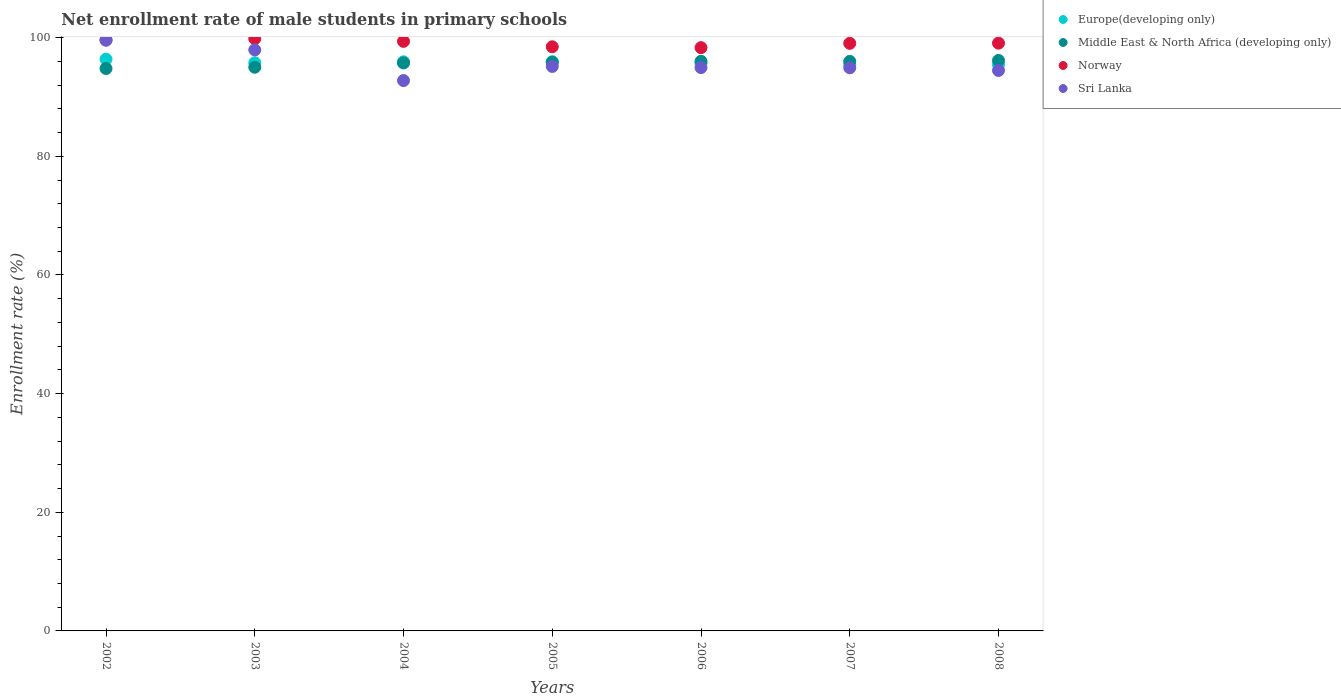Is the number of dotlines equal to the number of legend labels?
Provide a succinct answer. Yes. What is the net enrollment rate of male students in primary schools in Middle East & North Africa (developing only) in 2008?
Your answer should be very brief. 96.17. Across all years, what is the maximum net enrollment rate of male students in primary schools in Middle East & North Africa (developing only)?
Keep it short and to the point. 96.17. Across all years, what is the minimum net enrollment rate of male students in primary schools in Norway?
Your answer should be very brief. 98.32. In which year was the net enrollment rate of male students in primary schools in Europe(developing only) maximum?
Give a very brief answer. 2002. What is the total net enrollment rate of male students in primary schools in Europe(developing only) in the graph?
Ensure brevity in your answer.  670.72. What is the difference between the net enrollment rate of male students in primary schools in Norway in 2002 and that in 2008?
Your response must be concise. 0.55. What is the difference between the net enrollment rate of male students in primary schools in Europe(developing only) in 2003 and the net enrollment rate of male students in primary schools in Norway in 2008?
Keep it short and to the point. -3.31. What is the average net enrollment rate of male students in primary schools in Europe(developing only) per year?
Offer a very short reply. 95.82. In the year 2006, what is the difference between the net enrollment rate of male students in primary schools in Middle East & North Africa (developing only) and net enrollment rate of male students in primary schools in Norway?
Ensure brevity in your answer.  -2.3. What is the ratio of the net enrollment rate of male students in primary schools in Europe(developing only) in 2002 to that in 2007?
Your response must be concise. 1.01. What is the difference between the highest and the second highest net enrollment rate of male students in primary schools in Europe(developing only)?
Ensure brevity in your answer.  0.42. What is the difference between the highest and the lowest net enrollment rate of male students in primary schools in Sri Lanka?
Provide a succinct answer. 6.81. Is the sum of the net enrollment rate of male students in primary schools in Middle East & North Africa (developing only) in 2004 and 2007 greater than the maximum net enrollment rate of male students in primary schools in Europe(developing only) across all years?
Ensure brevity in your answer.  Yes. Does the net enrollment rate of male students in primary schools in Europe(developing only) monotonically increase over the years?
Make the answer very short. No. Is the net enrollment rate of male students in primary schools in Middle East & North Africa (developing only) strictly greater than the net enrollment rate of male students in primary schools in Europe(developing only) over the years?
Offer a terse response. No. Is the net enrollment rate of male students in primary schools in Sri Lanka strictly less than the net enrollment rate of male students in primary schools in Norway over the years?
Give a very brief answer. Yes. What is the difference between two consecutive major ticks on the Y-axis?
Make the answer very short. 20. Does the graph contain any zero values?
Provide a succinct answer. No. Does the graph contain grids?
Provide a succinct answer. No. How many legend labels are there?
Make the answer very short. 4. What is the title of the graph?
Ensure brevity in your answer.  Net enrollment rate of male students in primary schools. What is the label or title of the Y-axis?
Keep it short and to the point. Enrollment rate (%). What is the Enrollment rate (%) of Europe(developing only) in 2002?
Provide a short and direct response. 96.38. What is the Enrollment rate (%) of Middle East & North Africa (developing only) in 2002?
Provide a short and direct response. 94.81. What is the Enrollment rate (%) in Norway in 2002?
Keep it short and to the point. 99.63. What is the Enrollment rate (%) of Sri Lanka in 2002?
Offer a very short reply. 99.58. What is the Enrollment rate (%) in Europe(developing only) in 2003?
Make the answer very short. 95.78. What is the Enrollment rate (%) of Middle East & North Africa (developing only) in 2003?
Offer a very short reply. 95.02. What is the Enrollment rate (%) in Norway in 2003?
Keep it short and to the point. 99.84. What is the Enrollment rate (%) of Sri Lanka in 2003?
Your answer should be very brief. 97.95. What is the Enrollment rate (%) of Europe(developing only) in 2004?
Your response must be concise. 95.94. What is the Enrollment rate (%) in Middle East & North Africa (developing only) in 2004?
Offer a terse response. 95.75. What is the Enrollment rate (%) in Norway in 2004?
Your answer should be compact. 99.39. What is the Enrollment rate (%) of Sri Lanka in 2004?
Give a very brief answer. 92.78. What is the Enrollment rate (%) in Europe(developing only) in 2005?
Your answer should be very brief. 95.96. What is the Enrollment rate (%) of Middle East & North Africa (developing only) in 2005?
Offer a very short reply. 95.85. What is the Enrollment rate (%) of Norway in 2005?
Ensure brevity in your answer.  98.47. What is the Enrollment rate (%) in Sri Lanka in 2005?
Your answer should be compact. 95.16. What is the Enrollment rate (%) in Europe(developing only) in 2006?
Give a very brief answer. 95.71. What is the Enrollment rate (%) of Middle East & North Africa (developing only) in 2006?
Your answer should be compact. 96.03. What is the Enrollment rate (%) in Norway in 2006?
Give a very brief answer. 98.32. What is the Enrollment rate (%) in Sri Lanka in 2006?
Your response must be concise. 94.97. What is the Enrollment rate (%) in Europe(developing only) in 2007?
Offer a terse response. 95.49. What is the Enrollment rate (%) of Middle East & North Africa (developing only) in 2007?
Give a very brief answer. 96. What is the Enrollment rate (%) of Norway in 2007?
Give a very brief answer. 99.05. What is the Enrollment rate (%) in Sri Lanka in 2007?
Offer a terse response. 94.93. What is the Enrollment rate (%) of Europe(developing only) in 2008?
Offer a very short reply. 95.46. What is the Enrollment rate (%) in Middle East & North Africa (developing only) in 2008?
Offer a terse response. 96.17. What is the Enrollment rate (%) of Norway in 2008?
Your answer should be compact. 99.09. What is the Enrollment rate (%) in Sri Lanka in 2008?
Your answer should be very brief. 94.48. Across all years, what is the maximum Enrollment rate (%) of Europe(developing only)?
Make the answer very short. 96.38. Across all years, what is the maximum Enrollment rate (%) in Middle East & North Africa (developing only)?
Your answer should be compact. 96.17. Across all years, what is the maximum Enrollment rate (%) in Norway?
Give a very brief answer. 99.84. Across all years, what is the maximum Enrollment rate (%) in Sri Lanka?
Your answer should be compact. 99.58. Across all years, what is the minimum Enrollment rate (%) of Europe(developing only)?
Provide a short and direct response. 95.46. Across all years, what is the minimum Enrollment rate (%) of Middle East & North Africa (developing only)?
Keep it short and to the point. 94.81. Across all years, what is the minimum Enrollment rate (%) in Norway?
Provide a short and direct response. 98.32. Across all years, what is the minimum Enrollment rate (%) in Sri Lanka?
Give a very brief answer. 92.78. What is the total Enrollment rate (%) in Europe(developing only) in the graph?
Offer a terse response. 670.72. What is the total Enrollment rate (%) of Middle East & North Africa (developing only) in the graph?
Ensure brevity in your answer.  669.63. What is the total Enrollment rate (%) of Norway in the graph?
Your answer should be compact. 693.79. What is the total Enrollment rate (%) in Sri Lanka in the graph?
Provide a short and direct response. 669.84. What is the difference between the Enrollment rate (%) in Europe(developing only) in 2002 and that in 2003?
Provide a succinct answer. 0.6. What is the difference between the Enrollment rate (%) of Middle East & North Africa (developing only) in 2002 and that in 2003?
Ensure brevity in your answer.  -0.21. What is the difference between the Enrollment rate (%) in Norway in 2002 and that in 2003?
Provide a short and direct response. -0.21. What is the difference between the Enrollment rate (%) of Sri Lanka in 2002 and that in 2003?
Offer a terse response. 1.63. What is the difference between the Enrollment rate (%) in Europe(developing only) in 2002 and that in 2004?
Your answer should be compact. 0.44. What is the difference between the Enrollment rate (%) in Middle East & North Africa (developing only) in 2002 and that in 2004?
Keep it short and to the point. -0.94. What is the difference between the Enrollment rate (%) of Norway in 2002 and that in 2004?
Your answer should be very brief. 0.24. What is the difference between the Enrollment rate (%) of Sri Lanka in 2002 and that in 2004?
Provide a short and direct response. 6.81. What is the difference between the Enrollment rate (%) of Europe(developing only) in 2002 and that in 2005?
Your answer should be very brief. 0.42. What is the difference between the Enrollment rate (%) of Middle East & North Africa (developing only) in 2002 and that in 2005?
Offer a very short reply. -1.05. What is the difference between the Enrollment rate (%) of Norway in 2002 and that in 2005?
Your response must be concise. 1.16. What is the difference between the Enrollment rate (%) of Sri Lanka in 2002 and that in 2005?
Make the answer very short. 4.43. What is the difference between the Enrollment rate (%) in Europe(developing only) in 2002 and that in 2006?
Your answer should be compact. 0.67. What is the difference between the Enrollment rate (%) in Middle East & North Africa (developing only) in 2002 and that in 2006?
Provide a short and direct response. -1.22. What is the difference between the Enrollment rate (%) in Norway in 2002 and that in 2006?
Your answer should be compact. 1.31. What is the difference between the Enrollment rate (%) in Sri Lanka in 2002 and that in 2006?
Provide a short and direct response. 4.62. What is the difference between the Enrollment rate (%) in Europe(developing only) in 2002 and that in 2007?
Ensure brevity in your answer.  0.89. What is the difference between the Enrollment rate (%) of Middle East & North Africa (developing only) in 2002 and that in 2007?
Your response must be concise. -1.19. What is the difference between the Enrollment rate (%) in Norway in 2002 and that in 2007?
Give a very brief answer. 0.58. What is the difference between the Enrollment rate (%) of Sri Lanka in 2002 and that in 2007?
Provide a succinct answer. 4.65. What is the difference between the Enrollment rate (%) in Europe(developing only) in 2002 and that in 2008?
Your answer should be very brief. 0.92. What is the difference between the Enrollment rate (%) of Middle East & North Africa (developing only) in 2002 and that in 2008?
Provide a short and direct response. -1.36. What is the difference between the Enrollment rate (%) of Norway in 2002 and that in 2008?
Offer a very short reply. 0.55. What is the difference between the Enrollment rate (%) of Sri Lanka in 2002 and that in 2008?
Provide a short and direct response. 5.11. What is the difference between the Enrollment rate (%) in Europe(developing only) in 2003 and that in 2004?
Give a very brief answer. -0.16. What is the difference between the Enrollment rate (%) of Middle East & North Africa (developing only) in 2003 and that in 2004?
Your answer should be very brief. -0.72. What is the difference between the Enrollment rate (%) in Norway in 2003 and that in 2004?
Ensure brevity in your answer.  0.45. What is the difference between the Enrollment rate (%) in Sri Lanka in 2003 and that in 2004?
Your answer should be very brief. 5.17. What is the difference between the Enrollment rate (%) of Europe(developing only) in 2003 and that in 2005?
Your response must be concise. -0.18. What is the difference between the Enrollment rate (%) of Middle East & North Africa (developing only) in 2003 and that in 2005?
Provide a succinct answer. -0.83. What is the difference between the Enrollment rate (%) in Norway in 2003 and that in 2005?
Offer a very short reply. 1.37. What is the difference between the Enrollment rate (%) of Sri Lanka in 2003 and that in 2005?
Ensure brevity in your answer.  2.79. What is the difference between the Enrollment rate (%) of Europe(developing only) in 2003 and that in 2006?
Give a very brief answer. 0.07. What is the difference between the Enrollment rate (%) of Middle East & North Africa (developing only) in 2003 and that in 2006?
Make the answer very short. -1. What is the difference between the Enrollment rate (%) of Norway in 2003 and that in 2006?
Ensure brevity in your answer.  1.52. What is the difference between the Enrollment rate (%) of Sri Lanka in 2003 and that in 2006?
Offer a terse response. 2.98. What is the difference between the Enrollment rate (%) of Europe(developing only) in 2003 and that in 2007?
Make the answer very short. 0.29. What is the difference between the Enrollment rate (%) of Middle East & North Africa (developing only) in 2003 and that in 2007?
Offer a very short reply. -0.98. What is the difference between the Enrollment rate (%) of Norway in 2003 and that in 2007?
Make the answer very short. 0.79. What is the difference between the Enrollment rate (%) in Sri Lanka in 2003 and that in 2007?
Your answer should be compact. 3.02. What is the difference between the Enrollment rate (%) of Europe(developing only) in 2003 and that in 2008?
Your answer should be compact. 0.31. What is the difference between the Enrollment rate (%) in Middle East & North Africa (developing only) in 2003 and that in 2008?
Keep it short and to the point. -1.14. What is the difference between the Enrollment rate (%) in Norway in 2003 and that in 2008?
Make the answer very short. 0.75. What is the difference between the Enrollment rate (%) of Sri Lanka in 2003 and that in 2008?
Ensure brevity in your answer.  3.47. What is the difference between the Enrollment rate (%) of Europe(developing only) in 2004 and that in 2005?
Make the answer very short. -0.02. What is the difference between the Enrollment rate (%) of Middle East & North Africa (developing only) in 2004 and that in 2005?
Keep it short and to the point. -0.11. What is the difference between the Enrollment rate (%) in Norway in 2004 and that in 2005?
Provide a succinct answer. 0.92. What is the difference between the Enrollment rate (%) of Sri Lanka in 2004 and that in 2005?
Give a very brief answer. -2.38. What is the difference between the Enrollment rate (%) of Europe(developing only) in 2004 and that in 2006?
Your answer should be very brief. 0.23. What is the difference between the Enrollment rate (%) in Middle East & North Africa (developing only) in 2004 and that in 2006?
Your response must be concise. -0.28. What is the difference between the Enrollment rate (%) in Norway in 2004 and that in 2006?
Provide a succinct answer. 1.06. What is the difference between the Enrollment rate (%) in Sri Lanka in 2004 and that in 2006?
Your answer should be very brief. -2.19. What is the difference between the Enrollment rate (%) of Europe(developing only) in 2004 and that in 2007?
Your response must be concise. 0.45. What is the difference between the Enrollment rate (%) in Middle East & North Africa (developing only) in 2004 and that in 2007?
Keep it short and to the point. -0.26. What is the difference between the Enrollment rate (%) in Norway in 2004 and that in 2007?
Provide a succinct answer. 0.34. What is the difference between the Enrollment rate (%) in Sri Lanka in 2004 and that in 2007?
Make the answer very short. -2.15. What is the difference between the Enrollment rate (%) in Europe(developing only) in 2004 and that in 2008?
Provide a short and direct response. 0.48. What is the difference between the Enrollment rate (%) in Middle East & North Africa (developing only) in 2004 and that in 2008?
Provide a short and direct response. -0.42. What is the difference between the Enrollment rate (%) of Norway in 2004 and that in 2008?
Provide a short and direct response. 0.3. What is the difference between the Enrollment rate (%) of Sri Lanka in 2004 and that in 2008?
Keep it short and to the point. -1.7. What is the difference between the Enrollment rate (%) of Europe(developing only) in 2005 and that in 2006?
Offer a terse response. 0.25. What is the difference between the Enrollment rate (%) of Middle East & North Africa (developing only) in 2005 and that in 2006?
Give a very brief answer. -0.17. What is the difference between the Enrollment rate (%) in Norway in 2005 and that in 2006?
Provide a succinct answer. 0.15. What is the difference between the Enrollment rate (%) of Sri Lanka in 2005 and that in 2006?
Provide a succinct answer. 0.19. What is the difference between the Enrollment rate (%) in Europe(developing only) in 2005 and that in 2007?
Offer a terse response. 0.47. What is the difference between the Enrollment rate (%) in Middle East & North Africa (developing only) in 2005 and that in 2007?
Keep it short and to the point. -0.15. What is the difference between the Enrollment rate (%) in Norway in 2005 and that in 2007?
Offer a terse response. -0.58. What is the difference between the Enrollment rate (%) of Sri Lanka in 2005 and that in 2007?
Make the answer very short. 0.23. What is the difference between the Enrollment rate (%) of Europe(developing only) in 2005 and that in 2008?
Make the answer very short. 0.49. What is the difference between the Enrollment rate (%) in Middle East & North Africa (developing only) in 2005 and that in 2008?
Your response must be concise. -0.31. What is the difference between the Enrollment rate (%) of Norway in 2005 and that in 2008?
Offer a terse response. -0.61. What is the difference between the Enrollment rate (%) in Sri Lanka in 2005 and that in 2008?
Provide a short and direct response. 0.68. What is the difference between the Enrollment rate (%) of Europe(developing only) in 2006 and that in 2007?
Provide a succinct answer. 0.22. What is the difference between the Enrollment rate (%) of Middle East & North Africa (developing only) in 2006 and that in 2007?
Your answer should be very brief. 0.02. What is the difference between the Enrollment rate (%) in Norway in 2006 and that in 2007?
Give a very brief answer. -0.73. What is the difference between the Enrollment rate (%) of Sri Lanka in 2006 and that in 2007?
Provide a short and direct response. 0.04. What is the difference between the Enrollment rate (%) in Europe(developing only) in 2006 and that in 2008?
Offer a terse response. 0.25. What is the difference between the Enrollment rate (%) of Middle East & North Africa (developing only) in 2006 and that in 2008?
Offer a terse response. -0.14. What is the difference between the Enrollment rate (%) in Norway in 2006 and that in 2008?
Provide a succinct answer. -0.76. What is the difference between the Enrollment rate (%) of Sri Lanka in 2006 and that in 2008?
Offer a terse response. 0.49. What is the difference between the Enrollment rate (%) of Europe(developing only) in 2007 and that in 2008?
Keep it short and to the point. 0.02. What is the difference between the Enrollment rate (%) of Middle East & North Africa (developing only) in 2007 and that in 2008?
Provide a succinct answer. -0.16. What is the difference between the Enrollment rate (%) of Norway in 2007 and that in 2008?
Your response must be concise. -0.03. What is the difference between the Enrollment rate (%) in Sri Lanka in 2007 and that in 2008?
Your answer should be compact. 0.45. What is the difference between the Enrollment rate (%) of Europe(developing only) in 2002 and the Enrollment rate (%) of Middle East & North Africa (developing only) in 2003?
Provide a succinct answer. 1.36. What is the difference between the Enrollment rate (%) of Europe(developing only) in 2002 and the Enrollment rate (%) of Norway in 2003?
Offer a very short reply. -3.46. What is the difference between the Enrollment rate (%) of Europe(developing only) in 2002 and the Enrollment rate (%) of Sri Lanka in 2003?
Your response must be concise. -1.57. What is the difference between the Enrollment rate (%) of Middle East & North Africa (developing only) in 2002 and the Enrollment rate (%) of Norway in 2003?
Offer a terse response. -5.03. What is the difference between the Enrollment rate (%) of Middle East & North Africa (developing only) in 2002 and the Enrollment rate (%) of Sri Lanka in 2003?
Give a very brief answer. -3.14. What is the difference between the Enrollment rate (%) in Norway in 2002 and the Enrollment rate (%) in Sri Lanka in 2003?
Ensure brevity in your answer.  1.68. What is the difference between the Enrollment rate (%) of Europe(developing only) in 2002 and the Enrollment rate (%) of Middle East & North Africa (developing only) in 2004?
Provide a short and direct response. 0.63. What is the difference between the Enrollment rate (%) in Europe(developing only) in 2002 and the Enrollment rate (%) in Norway in 2004?
Provide a short and direct response. -3.01. What is the difference between the Enrollment rate (%) of Europe(developing only) in 2002 and the Enrollment rate (%) of Sri Lanka in 2004?
Give a very brief answer. 3.61. What is the difference between the Enrollment rate (%) of Middle East & North Africa (developing only) in 2002 and the Enrollment rate (%) of Norway in 2004?
Make the answer very short. -4.58. What is the difference between the Enrollment rate (%) of Middle East & North Africa (developing only) in 2002 and the Enrollment rate (%) of Sri Lanka in 2004?
Provide a short and direct response. 2.03. What is the difference between the Enrollment rate (%) in Norway in 2002 and the Enrollment rate (%) in Sri Lanka in 2004?
Keep it short and to the point. 6.86. What is the difference between the Enrollment rate (%) of Europe(developing only) in 2002 and the Enrollment rate (%) of Middle East & North Africa (developing only) in 2005?
Offer a terse response. 0.53. What is the difference between the Enrollment rate (%) of Europe(developing only) in 2002 and the Enrollment rate (%) of Norway in 2005?
Provide a short and direct response. -2.09. What is the difference between the Enrollment rate (%) of Europe(developing only) in 2002 and the Enrollment rate (%) of Sri Lanka in 2005?
Provide a succinct answer. 1.22. What is the difference between the Enrollment rate (%) in Middle East & North Africa (developing only) in 2002 and the Enrollment rate (%) in Norway in 2005?
Make the answer very short. -3.66. What is the difference between the Enrollment rate (%) of Middle East & North Africa (developing only) in 2002 and the Enrollment rate (%) of Sri Lanka in 2005?
Keep it short and to the point. -0.35. What is the difference between the Enrollment rate (%) in Norway in 2002 and the Enrollment rate (%) in Sri Lanka in 2005?
Your answer should be compact. 4.47. What is the difference between the Enrollment rate (%) in Europe(developing only) in 2002 and the Enrollment rate (%) in Middle East & North Africa (developing only) in 2006?
Your answer should be compact. 0.36. What is the difference between the Enrollment rate (%) in Europe(developing only) in 2002 and the Enrollment rate (%) in Norway in 2006?
Provide a succinct answer. -1.94. What is the difference between the Enrollment rate (%) in Europe(developing only) in 2002 and the Enrollment rate (%) in Sri Lanka in 2006?
Make the answer very short. 1.42. What is the difference between the Enrollment rate (%) of Middle East & North Africa (developing only) in 2002 and the Enrollment rate (%) of Norway in 2006?
Your response must be concise. -3.51. What is the difference between the Enrollment rate (%) in Middle East & North Africa (developing only) in 2002 and the Enrollment rate (%) in Sri Lanka in 2006?
Offer a very short reply. -0.16. What is the difference between the Enrollment rate (%) in Norway in 2002 and the Enrollment rate (%) in Sri Lanka in 2006?
Make the answer very short. 4.67. What is the difference between the Enrollment rate (%) in Europe(developing only) in 2002 and the Enrollment rate (%) in Middle East & North Africa (developing only) in 2007?
Provide a succinct answer. 0.38. What is the difference between the Enrollment rate (%) in Europe(developing only) in 2002 and the Enrollment rate (%) in Norway in 2007?
Your answer should be very brief. -2.67. What is the difference between the Enrollment rate (%) in Europe(developing only) in 2002 and the Enrollment rate (%) in Sri Lanka in 2007?
Your answer should be compact. 1.45. What is the difference between the Enrollment rate (%) in Middle East & North Africa (developing only) in 2002 and the Enrollment rate (%) in Norway in 2007?
Provide a succinct answer. -4.24. What is the difference between the Enrollment rate (%) of Middle East & North Africa (developing only) in 2002 and the Enrollment rate (%) of Sri Lanka in 2007?
Offer a terse response. -0.12. What is the difference between the Enrollment rate (%) of Norway in 2002 and the Enrollment rate (%) of Sri Lanka in 2007?
Offer a terse response. 4.7. What is the difference between the Enrollment rate (%) in Europe(developing only) in 2002 and the Enrollment rate (%) in Middle East & North Africa (developing only) in 2008?
Give a very brief answer. 0.22. What is the difference between the Enrollment rate (%) of Europe(developing only) in 2002 and the Enrollment rate (%) of Norway in 2008?
Provide a succinct answer. -2.7. What is the difference between the Enrollment rate (%) in Europe(developing only) in 2002 and the Enrollment rate (%) in Sri Lanka in 2008?
Ensure brevity in your answer.  1.9. What is the difference between the Enrollment rate (%) in Middle East & North Africa (developing only) in 2002 and the Enrollment rate (%) in Norway in 2008?
Keep it short and to the point. -4.28. What is the difference between the Enrollment rate (%) in Middle East & North Africa (developing only) in 2002 and the Enrollment rate (%) in Sri Lanka in 2008?
Make the answer very short. 0.33. What is the difference between the Enrollment rate (%) of Norway in 2002 and the Enrollment rate (%) of Sri Lanka in 2008?
Ensure brevity in your answer.  5.15. What is the difference between the Enrollment rate (%) in Europe(developing only) in 2003 and the Enrollment rate (%) in Middle East & North Africa (developing only) in 2004?
Offer a terse response. 0.03. What is the difference between the Enrollment rate (%) in Europe(developing only) in 2003 and the Enrollment rate (%) in Norway in 2004?
Your answer should be compact. -3.61. What is the difference between the Enrollment rate (%) in Europe(developing only) in 2003 and the Enrollment rate (%) in Sri Lanka in 2004?
Provide a succinct answer. 3. What is the difference between the Enrollment rate (%) of Middle East & North Africa (developing only) in 2003 and the Enrollment rate (%) of Norway in 2004?
Provide a succinct answer. -4.36. What is the difference between the Enrollment rate (%) in Middle East & North Africa (developing only) in 2003 and the Enrollment rate (%) in Sri Lanka in 2004?
Your response must be concise. 2.25. What is the difference between the Enrollment rate (%) in Norway in 2003 and the Enrollment rate (%) in Sri Lanka in 2004?
Your answer should be very brief. 7.06. What is the difference between the Enrollment rate (%) of Europe(developing only) in 2003 and the Enrollment rate (%) of Middle East & North Africa (developing only) in 2005?
Your response must be concise. -0.08. What is the difference between the Enrollment rate (%) in Europe(developing only) in 2003 and the Enrollment rate (%) in Norway in 2005?
Give a very brief answer. -2.69. What is the difference between the Enrollment rate (%) in Europe(developing only) in 2003 and the Enrollment rate (%) in Sri Lanka in 2005?
Your answer should be compact. 0.62. What is the difference between the Enrollment rate (%) of Middle East & North Africa (developing only) in 2003 and the Enrollment rate (%) of Norway in 2005?
Make the answer very short. -3.45. What is the difference between the Enrollment rate (%) of Middle East & North Africa (developing only) in 2003 and the Enrollment rate (%) of Sri Lanka in 2005?
Provide a succinct answer. -0.14. What is the difference between the Enrollment rate (%) of Norway in 2003 and the Enrollment rate (%) of Sri Lanka in 2005?
Your response must be concise. 4.68. What is the difference between the Enrollment rate (%) in Europe(developing only) in 2003 and the Enrollment rate (%) in Middle East & North Africa (developing only) in 2006?
Make the answer very short. -0.25. What is the difference between the Enrollment rate (%) of Europe(developing only) in 2003 and the Enrollment rate (%) of Norway in 2006?
Your answer should be very brief. -2.55. What is the difference between the Enrollment rate (%) in Europe(developing only) in 2003 and the Enrollment rate (%) in Sri Lanka in 2006?
Provide a succinct answer. 0.81. What is the difference between the Enrollment rate (%) of Middle East & North Africa (developing only) in 2003 and the Enrollment rate (%) of Norway in 2006?
Keep it short and to the point. -3.3. What is the difference between the Enrollment rate (%) of Middle East & North Africa (developing only) in 2003 and the Enrollment rate (%) of Sri Lanka in 2006?
Make the answer very short. 0.06. What is the difference between the Enrollment rate (%) of Norway in 2003 and the Enrollment rate (%) of Sri Lanka in 2006?
Your answer should be compact. 4.87. What is the difference between the Enrollment rate (%) of Europe(developing only) in 2003 and the Enrollment rate (%) of Middle East & North Africa (developing only) in 2007?
Offer a terse response. -0.23. What is the difference between the Enrollment rate (%) of Europe(developing only) in 2003 and the Enrollment rate (%) of Norway in 2007?
Offer a very short reply. -3.27. What is the difference between the Enrollment rate (%) in Europe(developing only) in 2003 and the Enrollment rate (%) in Sri Lanka in 2007?
Your response must be concise. 0.85. What is the difference between the Enrollment rate (%) in Middle East & North Africa (developing only) in 2003 and the Enrollment rate (%) in Norway in 2007?
Keep it short and to the point. -4.03. What is the difference between the Enrollment rate (%) in Middle East & North Africa (developing only) in 2003 and the Enrollment rate (%) in Sri Lanka in 2007?
Offer a very short reply. 0.09. What is the difference between the Enrollment rate (%) in Norway in 2003 and the Enrollment rate (%) in Sri Lanka in 2007?
Your response must be concise. 4.91. What is the difference between the Enrollment rate (%) of Europe(developing only) in 2003 and the Enrollment rate (%) of Middle East & North Africa (developing only) in 2008?
Offer a terse response. -0.39. What is the difference between the Enrollment rate (%) of Europe(developing only) in 2003 and the Enrollment rate (%) of Norway in 2008?
Your answer should be very brief. -3.31. What is the difference between the Enrollment rate (%) in Europe(developing only) in 2003 and the Enrollment rate (%) in Sri Lanka in 2008?
Your answer should be very brief. 1.3. What is the difference between the Enrollment rate (%) of Middle East & North Africa (developing only) in 2003 and the Enrollment rate (%) of Norway in 2008?
Your response must be concise. -4.06. What is the difference between the Enrollment rate (%) of Middle East & North Africa (developing only) in 2003 and the Enrollment rate (%) of Sri Lanka in 2008?
Make the answer very short. 0.54. What is the difference between the Enrollment rate (%) of Norway in 2003 and the Enrollment rate (%) of Sri Lanka in 2008?
Give a very brief answer. 5.36. What is the difference between the Enrollment rate (%) in Europe(developing only) in 2004 and the Enrollment rate (%) in Middle East & North Africa (developing only) in 2005?
Your answer should be very brief. 0.09. What is the difference between the Enrollment rate (%) in Europe(developing only) in 2004 and the Enrollment rate (%) in Norway in 2005?
Your answer should be compact. -2.53. What is the difference between the Enrollment rate (%) in Europe(developing only) in 2004 and the Enrollment rate (%) in Sri Lanka in 2005?
Give a very brief answer. 0.78. What is the difference between the Enrollment rate (%) in Middle East & North Africa (developing only) in 2004 and the Enrollment rate (%) in Norway in 2005?
Make the answer very short. -2.72. What is the difference between the Enrollment rate (%) in Middle East & North Africa (developing only) in 2004 and the Enrollment rate (%) in Sri Lanka in 2005?
Provide a short and direct response. 0.59. What is the difference between the Enrollment rate (%) of Norway in 2004 and the Enrollment rate (%) of Sri Lanka in 2005?
Your response must be concise. 4.23. What is the difference between the Enrollment rate (%) in Europe(developing only) in 2004 and the Enrollment rate (%) in Middle East & North Africa (developing only) in 2006?
Your answer should be very brief. -0.09. What is the difference between the Enrollment rate (%) of Europe(developing only) in 2004 and the Enrollment rate (%) of Norway in 2006?
Your response must be concise. -2.38. What is the difference between the Enrollment rate (%) of Europe(developing only) in 2004 and the Enrollment rate (%) of Sri Lanka in 2006?
Provide a succinct answer. 0.97. What is the difference between the Enrollment rate (%) in Middle East & North Africa (developing only) in 2004 and the Enrollment rate (%) in Norway in 2006?
Your answer should be very brief. -2.58. What is the difference between the Enrollment rate (%) in Middle East & North Africa (developing only) in 2004 and the Enrollment rate (%) in Sri Lanka in 2006?
Ensure brevity in your answer.  0.78. What is the difference between the Enrollment rate (%) in Norway in 2004 and the Enrollment rate (%) in Sri Lanka in 2006?
Ensure brevity in your answer.  4.42. What is the difference between the Enrollment rate (%) of Europe(developing only) in 2004 and the Enrollment rate (%) of Middle East & North Africa (developing only) in 2007?
Make the answer very short. -0.06. What is the difference between the Enrollment rate (%) of Europe(developing only) in 2004 and the Enrollment rate (%) of Norway in 2007?
Keep it short and to the point. -3.11. What is the difference between the Enrollment rate (%) in Europe(developing only) in 2004 and the Enrollment rate (%) in Sri Lanka in 2007?
Your response must be concise. 1.01. What is the difference between the Enrollment rate (%) in Middle East & North Africa (developing only) in 2004 and the Enrollment rate (%) in Norway in 2007?
Your response must be concise. -3.3. What is the difference between the Enrollment rate (%) in Middle East & North Africa (developing only) in 2004 and the Enrollment rate (%) in Sri Lanka in 2007?
Give a very brief answer. 0.82. What is the difference between the Enrollment rate (%) in Norway in 2004 and the Enrollment rate (%) in Sri Lanka in 2007?
Offer a terse response. 4.46. What is the difference between the Enrollment rate (%) in Europe(developing only) in 2004 and the Enrollment rate (%) in Middle East & North Africa (developing only) in 2008?
Keep it short and to the point. -0.23. What is the difference between the Enrollment rate (%) in Europe(developing only) in 2004 and the Enrollment rate (%) in Norway in 2008?
Ensure brevity in your answer.  -3.15. What is the difference between the Enrollment rate (%) of Europe(developing only) in 2004 and the Enrollment rate (%) of Sri Lanka in 2008?
Provide a short and direct response. 1.46. What is the difference between the Enrollment rate (%) in Middle East & North Africa (developing only) in 2004 and the Enrollment rate (%) in Norway in 2008?
Ensure brevity in your answer.  -3.34. What is the difference between the Enrollment rate (%) in Middle East & North Africa (developing only) in 2004 and the Enrollment rate (%) in Sri Lanka in 2008?
Your answer should be compact. 1.27. What is the difference between the Enrollment rate (%) of Norway in 2004 and the Enrollment rate (%) of Sri Lanka in 2008?
Provide a short and direct response. 4.91. What is the difference between the Enrollment rate (%) in Europe(developing only) in 2005 and the Enrollment rate (%) in Middle East & North Africa (developing only) in 2006?
Make the answer very short. -0.07. What is the difference between the Enrollment rate (%) of Europe(developing only) in 2005 and the Enrollment rate (%) of Norway in 2006?
Offer a very short reply. -2.37. What is the difference between the Enrollment rate (%) of Middle East & North Africa (developing only) in 2005 and the Enrollment rate (%) of Norway in 2006?
Your answer should be compact. -2.47. What is the difference between the Enrollment rate (%) of Middle East & North Africa (developing only) in 2005 and the Enrollment rate (%) of Sri Lanka in 2006?
Your response must be concise. 0.89. What is the difference between the Enrollment rate (%) of Norway in 2005 and the Enrollment rate (%) of Sri Lanka in 2006?
Your answer should be very brief. 3.51. What is the difference between the Enrollment rate (%) in Europe(developing only) in 2005 and the Enrollment rate (%) in Middle East & North Africa (developing only) in 2007?
Provide a succinct answer. -0.05. What is the difference between the Enrollment rate (%) in Europe(developing only) in 2005 and the Enrollment rate (%) in Norway in 2007?
Offer a terse response. -3.09. What is the difference between the Enrollment rate (%) of Europe(developing only) in 2005 and the Enrollment rate (%) of Sri Lanka in 2007?
Your response must be concise. 1.03. What is the difference between the Enrollment rate (%) of Middle East & North Africa (developing only) in 2005 and the Enrollment rate (%) of Norway in 2007?
Make the answer very short. -3.2. What is the difference between the Enrollment rate (%) in Middle East & North Africa (developing only) in 2005 and the Enrollment rate (%) in Sri Lanka in 2007?
Your response must be concise. 0.92. What is the difference between the Enrollment rate (%) in Norway in 2005 and the Enrollment rate (%) in Sri Lanka in 2007?
Provide a succinct answer. 3.54. What is the difference between the Enrollment rate (%) in Europe(developing only) in 2005 and the Enrollment rate (%) in Middle East & North Africa (developing only) in 2008?
Your answer should be compact. -0.21. What is the difference between the Enrollment rate (%) in Europe(developing only) in 2005 and the Enrollment rate (%) in Norway in 2008?
Provide a short and direct response. -3.13. What is the difference between the Enrollment rate (%) of Europe(developing only) in 2005 and the Enrollment rate (%) of Sri Lanka in 2008?
Provide a short and direct response. 1.48. What is the difference between the Enrollment rate (%) of Middle East & North Africa (developing only) in 2005 and the Enrollment rate (%) of Norway in 2008?
Your answer should be very brief. -3.23. What is the difference between the Enrollment rate (%) in Middle East & North Africa (developing only) in 2005 and the Enrollment rate (%) in Sri Lanka in 2008?
Give a very brief answer. 1.38. What is the difference between the Enrollment rate (%) of Norway in 2005 and the Enrollment rate (%) of Sri Lanka in 2008?
Your response must be concise. 3.99. What is the difference between the Enrollment rate (%) of Europe(developing only) in 2006 and the Enrollment rate (%) of Middle East & North Africa (developing only) in 2007?
Your answer should be compact. -0.29. What is the difference between the Enrollment rate (%) of Europe(developing only) in 2006 and the Enrollment rate (%) of Norway in 2007?
Provide a succinct answer. -3.34. What is the difference between the Enrollment rate (%) in Europe(developing only) in 2006 and the Enrollment rate (%) in Sri Lanka in 2007?
Give a very brief answer. 0.78. What is the difference between the Enrollment rate (%) in Middle East & North Africa (developing only) in 2006 and the Enrollment rate (%) in Norway in 2007?
Your response must be concise. -3.03. What is the difference between the Enrollment rate (%) of Middle East & North Africa (developing only) in 2006 and the Enrollment rate (%) of Sri Lanka in 2007?
Offer a very short reply. 1.1. What is the difference between the Enrollment rate (%) of Norway in 2006 and the Enrollment rate (%) of Sri Lanka in 2007?
Provide a short and direct response. 3.39. What is the difference between the Enrollment rate (%) in Europe(developing only) in 2006 and the Enrollment rate (%) in Middle East & North Africa (developing only) in 2008?
Your answer should be compact. -0.45. What is the difference between the Enrollment rate (%) in Europe(developing only) in 2006 and the Enrollment rate (%) in Norway in 2008?
Your answer should be compact. -3.37. What is the difference between the Enrollment rate (%) of Europe(developing only) in 2006 and the Enrollment rate (%) of Sri Lanka in 2008?
Keep it short and to the point. 1.23. What is the difference between the Enrollment rate (%) of Middle East & North Africa (developing only) in 2006 and the Enrollment rate (%) of Norway in 2008?
Keep it short and to the point. -3.06. What is the difference between the Enrollment rate (%) in Middle East & North Africa (developing only) in 2006 and the Enrollment rate (%) in Sri Lanka in 2008?
Offer a very short reply. 1.55. What is the difference between the Enrollment rate (%) in Norway in 2006 and the Enrollment rate (%) in Sri Lanka in 2008?
Your answer should be very brief. 3.84. What is the difference between the Enrollment rate (%) of Europe(developing only) in 2007 and the Enrollment rate (%) of Middle East & North Africa (developing only) in 2008?
Provide a short and direct response. -0.68. What is the difference between the Enrollment rate (%) of Europe(developing only) in 2007 and the Enrollment rate (%) of Norway in 2008?
Provide a short and direct response. -3.6. What is the difference between the Enrollment rate (%) in Europe(developing only) in 2007 and the Enrollment rate (%) in Sri Lanka in 2008?
Give a very brief answer. 1.01. What is the difference between the Enrollment rate (%) of Middle East & North Africa (developing only) in 2007 and the Enrollment rate (%) of Norway in 2008?
Make the answer very short. -3.08. What is the difference between the Enrollment rate (%) in Middle East & North Africa (developing only) in 2007 and the Enrollment rate (%) in Sri Lanka in 2008?
Your answer should be compact. 1.52. What is the difference between the Enrollment rate (%) in Norway in 2007 and the Enrollment rate (%) in Sri Lanka in 2008?
Ensure brevity in your answer.  4.57. What is the average Enrollment rate (%) in Europe(developing only) per year?
Offer a very short reply. 95.82. What is the average Enrollment rate (%) of Middle East & North Africa (developing only) per year?
Offer a terse response. 95.66. What is the average Enrollment rate (%) of Norway per year?
Keep it short and to the point. 99.11. What is the average Enrollment rate (%) of Sri Lanka per year?
Offer a very short reply. 95.69. In the year 2002, what is the difference between the Enrollment rate (%) of Europe(developing only) and Enrollment rate (%) of Middle East & North Africa (developing only)?
Offer a very short reply. 1.57. In the year 2002, what is the difference between the Enrollment rate (%) of Europe(developing only) and Enrollment rate (%) of Norway?
Your response must be concise. -3.25. In the year 2002, what is the difference between the Enrollment rate (%) in Europe(developing only) and Enrollment rate (%) in Sri Lanka?
Your response must be concise. -3.2. In the year 2002, what is the difference between the Enrollment rate (%) in Middle East & North Africa (developing only) and Enrollment rate (%) in Norway?
Your answer should be very brief. -4.82. In the year 2002, what is the difference between the Enrollment rate (%) of Middle East & North Africa (developing only) and Enrollment rate (%) of Sri Lanka?
Give a very brief answer. -4.78. In the year 2002, what is the difference between the Enrollment rate (%) of Norway and Enrollment rate (%) of Sri Lanka?
Your answer should be compact. 0.05. In the year 2003, what is the difference between the Enrollment rate (%) in Europe(developing only) and Enrollment rate (%) in Middle East & North Africa (developing only)?
Keep it short and to the point. 0.75. In the year 2003, what is the difference between the Enrollment rate (%) in Europe(developing only) and Enrollment rate (%) in Norway?
Make the answer very short. -4.06. In the year 2003, what is the difference between the Enrollment rate (%) of Europe(developing only) and Enrollment rate (%) of Sri Lanka?
Offer a terse response. -2.17. In the year 2003, what is the difference between the Enrollment rate (%) of Middle East & North Africa (developing only) and Enrollment rate (%) of Norway?
Your answer should be very brief. -4.82. In the year 2003, what is the difference between the Enrollment rate (%) of Middle East & North Africa (developing only) and Enrollment rate (%) of Sri Lanka?
Your answer should be compact. -2.93. In the year 2003, what is the difference between the Enrollment rate (%) in Norway and Enrollment rate (%) in Sri Lanka?
Offer a terse response. 1.89. In the year 2004, what is the difference between the Enrollment rate (%) in Europe(developing only) and Enrollment rate (%) in Middle East & North Africa (developing only)?
Provide a succinct answer. 0.19. In the year 2004, what is the difference between the Enrollment rate (%) of Europe(developing only) and Enrollment rate (%) of Norway?
Provide a short and direct response. -3.45. In the year 2004, what is the difference between the Enrollment rate (%) in Europe(developing only) and Enrollment rate (%) in Sri Lanka?
Offer a terse response. 3.16. In the year 2004, what is the difference between the Enrollment rate (%) of Middle East & North Africa (developing only) and Enrollment rate (%) of Norway?
Your answer should be compact. -3.64. In the year 2004, what is the difference between the Enrollment rate (%) of Middle East & North Africa (developing only) and Enrollment rate (%) of Sri Lanka?
Your answer should be compact. 2.97. In the year 2004, what is the difference between the Enrollment rate (%) in Norway and Enrollment rate (%) in Sri Lanka?
Give a very brief answer. 6.61. In the year 2005, what is the difference between the Enrollment rate (%) in Europe(developing only) and Enrollment rate (%) in Middle East & North Africa (developing only)?
Your response must be concise. 0.1. In the year 2005, what is the difference between the Enrollment rate (%) in Europe(developing only) and Enrollment rate (%) in Norway?
Offer a very short reply. -2.51. In the year 2005, what is the difference between the Enrollment rate (%) in Europe(developing only) and Enrollment rate (%) in Sri Lanka?
Ensure brevity in your answer.  0.8. In the year 2005, what is the difference between the Enrollment rate (%) of Middle East & North Africa (developing only) and Enrollment rate (%) of Norway?
Your answer should be very brief. -2.62. In the year 2005, what is the difference between the Enrollment rate (%) of Middle East & North Africa (developing only) and Enrollment rate (%) of Sri Lanka?
Provide a short and direct response. 0.7. In the year 2005, what is the difference between the Enrollment rate (%) in Norway and Enrollment rate (%) in Sri Lanka?
Offer a terse response. 3.31. In the year 2006, what is the difference between the Enrollment rate (%) in Europe(developing only) and Enrollment rate (%) in Middle East & North Africa (developing only)?
Make the answer very short. -0.31. In the year 2006, what is the difference between the Enrollment rate (%) in Europe(developing only) and Enrollment rate (%) in Norway?
Ensure brevity in your answer.  -2.61. In the year 2006, what is the difference between the Enrollment rate (%) of Europe(developing only) and Enrollment rate (%) of Sri Lanka?
Offer a very short reply. 0.75. In the year 2006, what is the difference between the Enrollment rate (%) of Middle East & North Africa (developing only) and Enrollment rate (%) of Norway?
Make the answer very short. -2.3. In the year 2006, what is the difference between the Enrollment rate (%) of Middle East & North Africa (developing only) and Enrollment rate (%) of Sri Lanka?
Provide a short and direct response. 1.06. In the year 2006, what is the difference between the Enrollment rate (%) of Norway and Enrollment rate (%) of Sri Lanka?
Provide a succinct answer. 3.36. In the year 2007, what is the difference between the Enrollment rate (%) of Europe(developing only) and Enrollment rate (%) of Middle East & North Africa (developing only)?
Make the answer very short. -0.52. In the year 2007, what is the difference between the Enrollment rate (%) in Europe(developing only) and Enrollment rate (%) in Norway?
Ensure brevity in your answer.  -3.56. In the year 2007, what is the difference between the Enrollment rate (%) in Europe(developing only) and Enrollment rate (%) in Sri Lanka?
Make the answer very short. 0.56. In the year 2007, what is the difference between the Enrollment rate (%) in Middle East & North Africa (developing only) and Enrollment rate (%) in Norway?
Your answer should be compact. -3.05. In the year 2007, what is the difference between the Enrollment rate (%) in Middle East & North Africa (developing only) and Enrollment rate (%) in Sri Lanka?
Provide a short and direct response. 1.07. In the year 2007, what is the difference between the Enrollment rate (%) in Norway and Enrollment rate (%) in Sri Lanka?
Ensure brevity in your answer.  4.12. In the year 2008, what is the difference between the Enrollment rate (%) of Europe(developing only) and Enrollment rate (%) of Middle East & North Africa (developing only)?
Give a very brief answer. -0.7. In the year 2008, what is the difference between the Enrollment rate (%) of Europe(developing only) and Enrollment rate (%) of Norway?
Your answer should be compact. -3.62. In the year 2008, what is the difference between the Enrollment rate (%) in Europe(developing only) and Enrollment rate (%) in Sri Lanka?
Your answer should be very brief. 0.98. In the year 2008, what is the difference between the Enrollment rate (%) in Middle East & North Africa (developing only) and Enrollment rate (%) in Norway?
Provide a short and direct response. -2.92. In the year 2008, what is the difference between the Enrollment rate (%) of Middle East & North Africa (developing only) and Enrollment rate (%) of Sri Lanka?
Your response must be concise. 1.69. In the year 2008, what is the difference between the Enrollment rate (%) in Norway and Enrollment rate (%) in Sri Lanka?
Provide a short and direct response. 4.61. What is the ratio of the Enrollment rate (%) of Middle East & North Africa (developing only) in 2002 to that in 2003?
Make the answer very short. 1. What is the ratio of the Enrollment rate (%) of Sri Lanka in 2002 to that in 2003?
Offer a terse response. 1.02. What is the ratio of the Enrollment rate (%) of Middle East & North Africa (developing only) in 2002 to that in 2004?
Keep it short and to the point. 0.99. What is the ratio of the Enrollment rate (%) of Norway in 2002 to that in 2004?
Provide a succinct answer. 1. What is the ratio of the Enrollment rate (%) of Sri Lanka in 2002 to that in 2004?
Provide a short and direct response. 1.07. What is the ratio of the Enrollment rate (%) of Middle East & North Africa (developing only) in 2002 to that in 2005?
Provide a short and direct response. 0.99. What is the ratio of the Enrollment rate (%) in Norway in 2002 to that in 2005?
Your answer should be very brief. 1.01. What is the ratio of the Enrollment rate (%) of Sri Lanka in 2002 to that in 2005?
Give a very brief answer. 1.05. What is the ratio of the Enrollment rate (%) in Middle East & North Africa (developing only) in 2002 to that in 2006?
Provide a succinct answer. 0.99. What is the ratio of the Enrollment rate (%) of Norway in 2002 to that in 2006?
Your answer should be compact. 1.01. What is the ratio of the Enrollment rate (%) of Sri Lanka in 2002 to that in 2006?
Provide a succinct answer. 1.05. What is the ratio of the Enrollment rate (%) in Europe(developing only) in 2002 to that in 2007?
Provide a short and direct response. 1.01. What is the ratio of the Enrollment rate (%) of Middle East & North Africa (developing only) in 2002 to that in 2007?
Provide a short and direct response. 0.99. What is the ratio of the Enrollment rate (%) of Norway in 2002 to that in 2007?
Keep it short and to the point. 1.01. What is the ratio of the Enrollment rate (%) in Sri Lanka in 2002 to that in 2007?
Give a very brief answer. 1.05. What is the ratio of the Enrollment rate (%) in Europe(developing only) in 2002 to that in 2008?
Ensure brevity in your answer.  1.01. What is the ratio of the Enrollment rate (%) in Middle East & North Africa (developing only) in 2002 to that in 2008?
Give a very brief answer. 0.99. What is the ratio of the Enrollment rate (%) in Norway in 2002 to that in 2008?
Ensure brevity in your answer.  1.01. What is the ratio of the Enrollment rate (%) in Sri Lanka in 2002 to that in 2008?
Ensure brevity in your answer.  1.05. What is the ratio of the Enrollment rate (%) of Europe(developing only) in 2003 to that in 2004?
Provide a short and direct response. 1. What is the ratio of the Enrollment rate (%) in Sri Lanka in 2003 to that in 2004?
Your answer should be very brief. 1.06. What is the ratio of the Enrollment rate (%) in Europe(developing only) in 2003 to that in 2005?
Your response must be concise. 1. What is the ratio of the Enrollment rate (%) of Norway in 2003 to that in 2005?
Provide a succinct answer. 1.01. What is the ratio of the Enrollment rate (%) of Sri Lanka in 2003 to that in 2005?
Ensure brevity in your answer.  1.03. What is the ratio of the Enrollment rate (%) of Europe(developing only) in 2003 to that in 2006?
Offer a terse response. 1. What is the ratio of the Enrollment rate (%) of Norway in 2003 to that in 2006?
Give a very brief answer. 1.02. What is the ratio of the Enrollment rate (%) in Sri Lanka in 2003 to that in 2006?
Offer a terse response. 1.03. What is the ratio of the Enrollment rate (%) of Europe(developing only) in 2003 to that in 2007?
Your response must be concise. 1. What is the ratio of the Enrollment rate (%) of Norway in 2003 to that in 2007?
Give a very brief answer. 1.01. What is the ratio of the Enrollment rate (%) in Sri Lanka in 2003 to that in 2007?
Keep it short and to the point. 1.03. What is the ratio of the Enrollment rate (%) in Europe(developing only) in 2003 to that in 2008?
Your answer should be very brief. 1. What is the ratio of the Enrollment rate (%) of Middle East & North Africa (developing only) in 2003 to that in 2008?
Offer a terse response. 0.99. What is the ratio of the Enrollment rate (%) in Norway in 2003 to that in 2008?
Provide a succinct answer. 1.01. What is the ratio of the Enrollment rate (%) in Sri Lanka in 2003 to that in 2008?
Ensure brevity in your answer.  1.04. What is the ratio of the Enrollment rate (%) of Norway in 2004 to that in 2005?
Provide a succinct answer. 1.01. What is the ratio of the Enrollment rate (%) of Sri Lanka in 2004 to that in 2005?
Give a very brief answer. 0.97. What is the ratio of the Enrollment rate (%) of Europe(developing only) in 2004 to that in 2006?
Keep it short and to the point. 1. What is the ratio of the Enrollment rate (%) in Norway in 2004 to that in 2006?
Your response must be concise. 1.01. What is the ratio of the Enrollment rate (%) in Sri Lanka in 2004 to that in 2006?
Keep it short and to the point. 0.98. What is the ratio of the Enrollment rate (%) of Middle East & North Africa (developing only) in 2004 to that in 2007?
Your answer should be compact. 1. What is the ratio of the Enrollment rate (%) of Sri Lanka in 2004 to that in 2007?
Give a very brief answer. 0.98. What is the ratio of the Enrollment rate (%) of Europe(developing only) in 2004 to that in 2008?
Ensure brevity in your answer.  1. What is the ratio of the Enrollment rate (%) in Middle East & North Africa (developing only) in 2004 to that in 2008?
Provide a short and direct response. 1. What is the ratio of the Enrollment rate (%) of Norway in 2005 to that in 2006?
Give a very brief answer. 1. What is the ratio of the Enrollment rate (%) of Europe(developing only) in 2005 to that in 2007?
Keep it short and to the point. 1. What is the ratio of the Enrollment rate (%) of Middle East & North Africa (developing only) in 2005 to that in 2007?
Your answer should be compact. 1. What is the ratio of the Enrollment rate (%) of Norway in 2005 to that in 2007?
Provide a short and direct response. 0.99. What is the ratio of the Enrollment rate (%) in Sri Lanka in 2005 to that in 2007?
Keep it short and to the point. 1. What is the ratio of the Enrollment rate (%) in Middle East & North Africa (developing only) in 2006 to that in 2007?
Give a very brief answer. 1. What is the ratio of the Enrollment rate (%) in Europe(developing only) in 2006 to that in 2008?
Offer a terse response. 1. What is the ratio of the Enrollment rate (%) of Middle East & North Africa (developing only) in 2006 to that in 2008?
Provide a succinct answer. 1. What is the ratio of the Enrollment rate (%) in Norway in 2006 to that in 2008?
Offer a terse response. 0.99. What is the ratio of the Enrollment rate (%) in Europe(developing only) in 2007 to that in 2008?
Ensure brevity in your answer.  1. What is the difference between the highest and the second highest Enrollment rate (%) in Europe(developing only)?
Provide a short and direct response. 0.42. What is the difference between the highest and the second highest Enrollment rate (%) in Middle East & North Africa (developing only)?
Ensure brevity in your answer.  0.14. What is the difference between the highest and the second highest Enrollment rate (%) of Norway?
Provide a succinct answer. 0.21. What is the difference between the highest and the second highest Enrollment rate (%) in Sri Lanka?
Keep it short and to the point. 1.63. What is the difference between the highest and the lowest Enrollment rate (%) of Europe(developing only)?
Your answer should be very brief. 0.92. What is the difference between the highest and the lowest Enrollment rate (%) of Middle East & North Africa (developing only)?
Make the answer very short. 1.36. What is the difference between the highest and the lowest Enrollment rate (%) of Norway?
Offer a terse response. 1.52. What is the difference between the highest and the lowest Enrollment rate (%) of Sri Lanka?
Your answer should be compact. 6.81. 